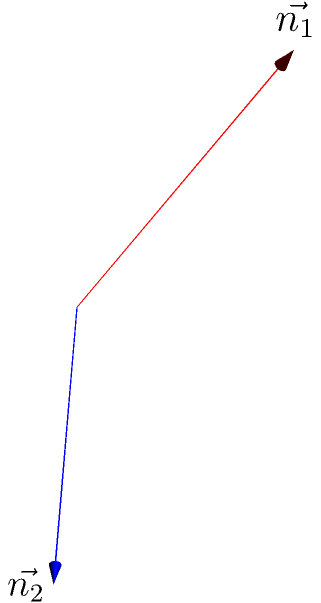As a ripple effects analyst, you're assessing the impact of adding a new feature that involves calculating the angle between two planes in 3D space. Given two planes represented by their normal vectors $\vec{n_1} = (1, 2, 2)$ and $\vec{n_2} = (2, 1, -1)$, calculate the angle $\theta$ between these planes. How might this calculation affect the user experience of the new feature? To find the angle between two planes represented by their normal vectors, we can use the dot product formula:

1) The formula for the angle between two vectors is:
   $$\cos \theta = \frac{\vec{n_1} \cdot \vec{n_2}}{|\vec{n_1}| |\vec{n_2}|}$$

2) Calculate the dot product $\vec{n_1} \cdot \vec{n_2}$:
   $$(1 \cdot 2) + (2 \cdot 1) + (2 \cdot (-1)) = 2 + 2 - 2 = 2$$

3) Calculate the magnitudes of the vectors:
   $$|\vec{n_1}| = \sqrt{1^2 + 2^2 + 2^2} = \sqrt{9} = 3$$
   $$|\vec{n_2}| = \sqrt{2^2 + 1^2 + (-1)^2} = \sqrt{6}$$

4) Substitute into the formula:
   $$\cos \theta = \frac{2}{3\sqrt{6}}$$

5) Take the inverse cosine (arccos) of both sides:
   $$\theta = \arccos(\frac{2}{3\sqrt{6}}) \approx 1.249 \text{ radians} \approx 71.57°$$

This calculation allows users to understand the spatial relationship between planes, which could be crucial for various applications such as 3D modeling, computer graphics, or structural analysis. The accuracy and speed of this calculation directly impact the user experience, especially if real-time interactions are involved.
Answer: $\theta = \arccos(\frac{2}{3\sqrt{6}}) \approx 71.57°$ 